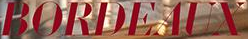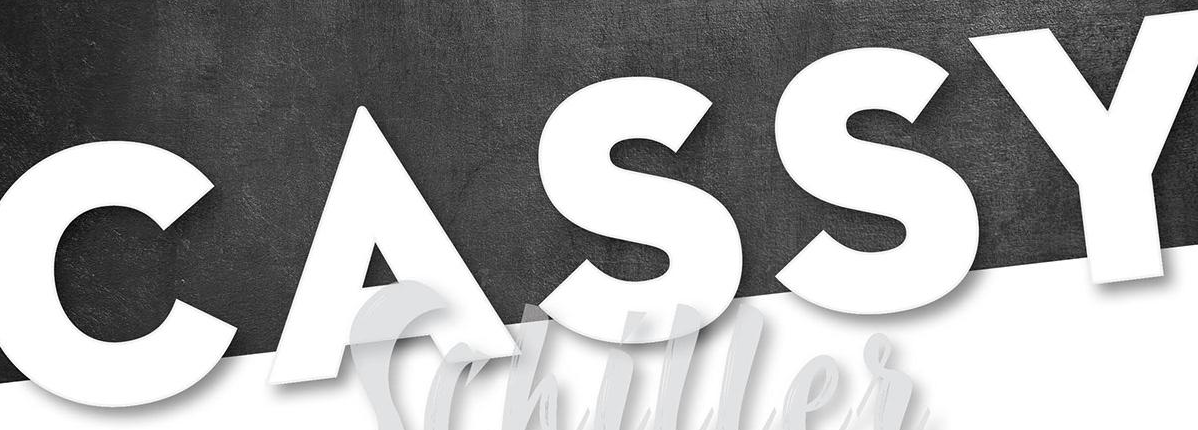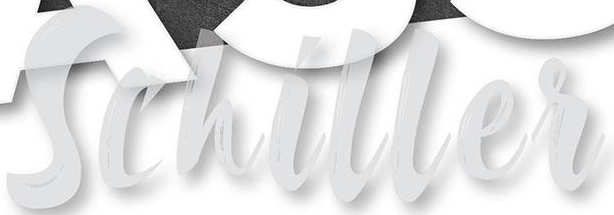Transcribe the words shown in these images in order, separated by a semicolon. BORDEAUX; CASSY; Schiller 